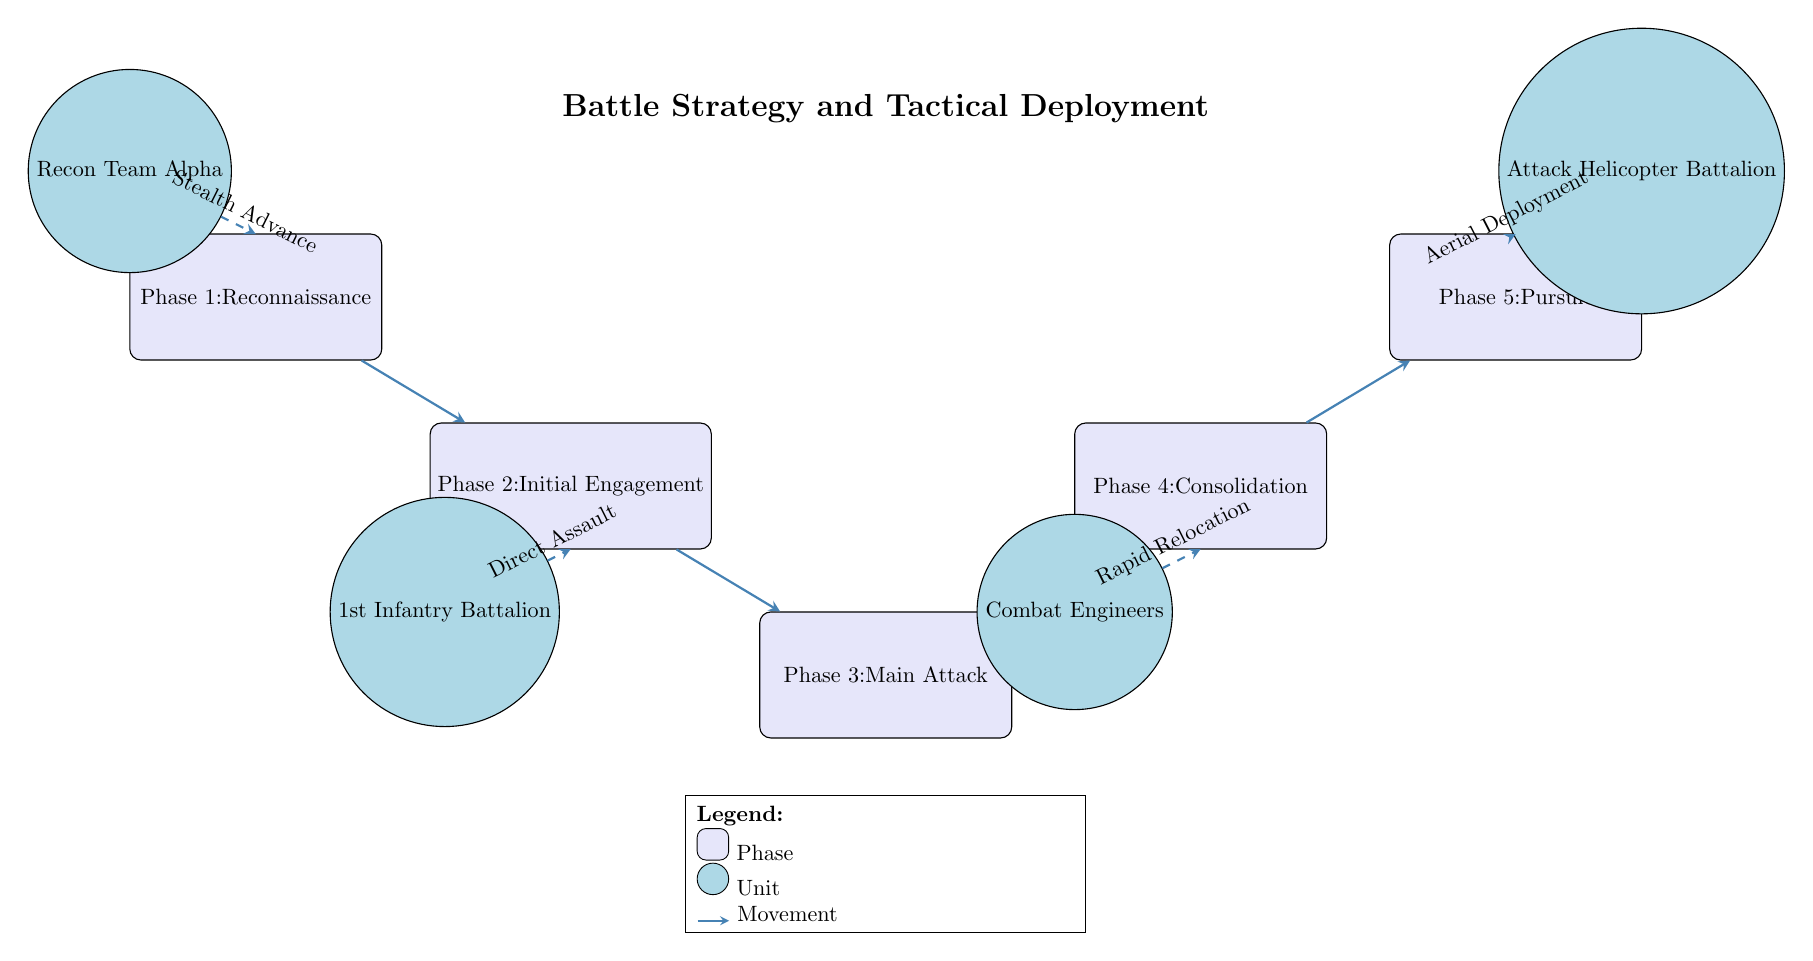What is the first phase of the battle strategy? The diagram labels the first phase at the top with "Phase 1: Reconnaissance." This is the text seen on the corresponding phase node.
Answer: Reconnaissance How many total phases are illustrated in the diagram? The diagram shows five distinct phases, each represented by a labeled node. Counting the nodes from Phase 1 through Phase 5 confirms there are five phases.
Answer: 5 What unit is associated with Phase 2? Phase 2 is linked to the "1st Infantry Battalion" which is represented by the circular unit node located below Phase 2.
Answer: 1st Infantry Battalion What type of movement is indicated by the arrow from the "Recon Team Alpha" to Phase 2? The arrow from "Recon Team Alpha" is dashed and labeled “Stealth Advance,” indicating the nature of the movement towards Phase 2.
Answer: Stealth Advance What is the last phase of the diagram? The diagram indicates that the last phase is labeled as "Phase 5: Pursuit," which is positioned at the far right of the diagram.
Answer: Pursuit Which unit performs a "Rapid Relocation"? The diagram shows that "Combat Engineers" are associated with the movement labeled “Rapid Relocation,” indicated by the dashed arrow pointing from their node.
Answer: Combat Engineers Which phase comes after the "Main Attack"? The structure of the diagram shows an arrow leading from "Phase 3: Main Attack" to "Phase 4: Consolidation," indicating that Consolidation follows the Main Attack.
Answer: Consolidation How many units are depicted in the diagram? There are four distinct units illustrated, namely "Recon Team Alpha," "1st Infantry Battalion," "Combat Engineers," and "Attack Helicopter Battalion."
Answer: 4 What type of diagram is this? The diagram is best categorized as a "Battle Strategy and Tactical Deployment Diagram" based on its title and the content it illustrates regarding military operations.
Answer: Battle Strategy and Tactical Deployment Diagram 